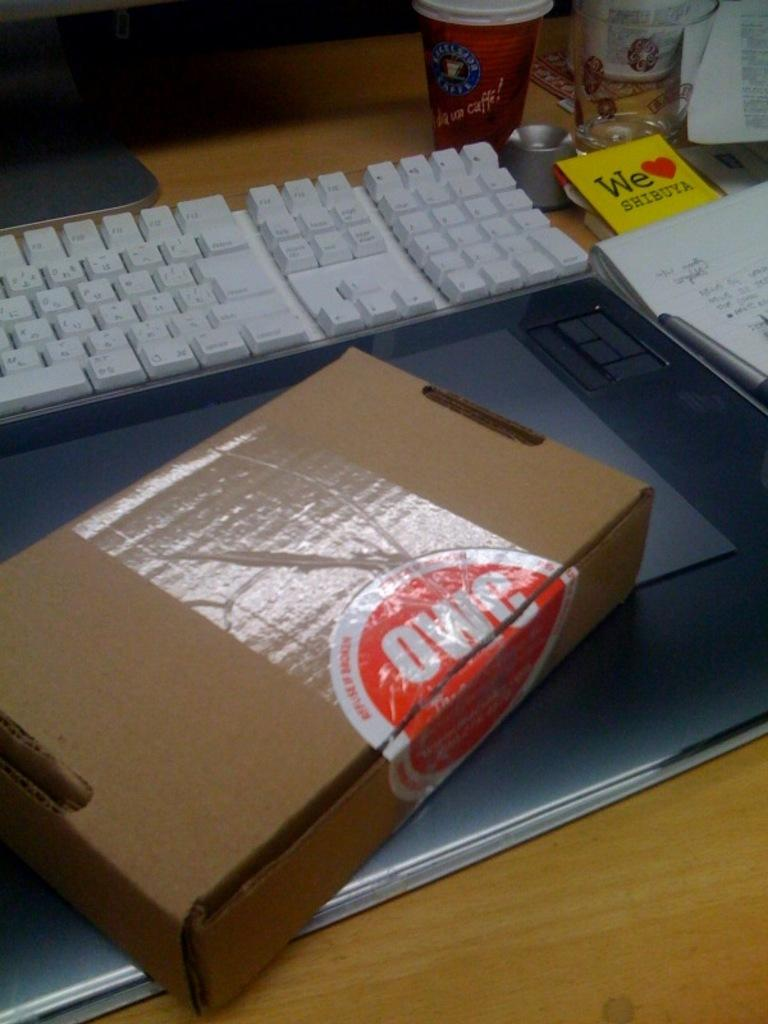<image>
Create a compact narrative representing the image presented. A crowded desk contains a keyboard, a cardboard box, a cup, notepad, and a paper that says, "We love Shibuya". 